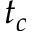Convert formula to latex. <formula><loc_0><loc_0><loc_500><loc_500>t _ { c }</formula> 